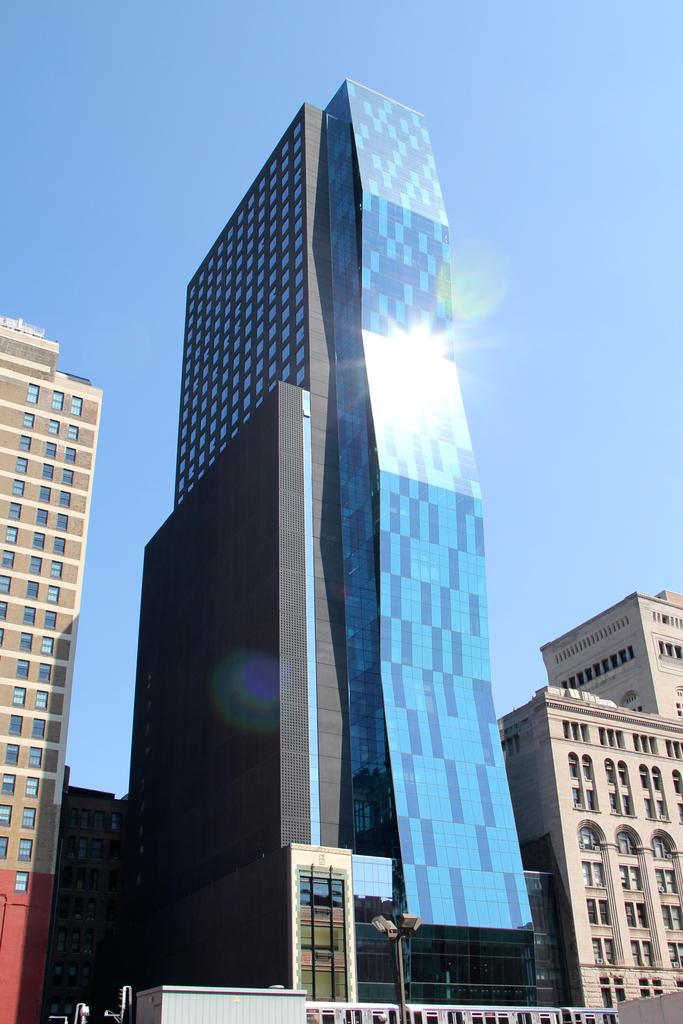What can be seen in the image? There are many buildings in the image. Can you describe a specific building in the image? There is a building with windows on the right side of the image. What is located in the front of the image? There is a street light pole in the front of the image. What is visible in the background of the image? The sky is visible in the background of the image. How many examples of development can be seen in the image? There is no direct reference to "development" in the image, so it's not possible to answer that question. How many cars are parked on the street in the image? There is no information about cars in the image, so it's not possible to answer that question. 